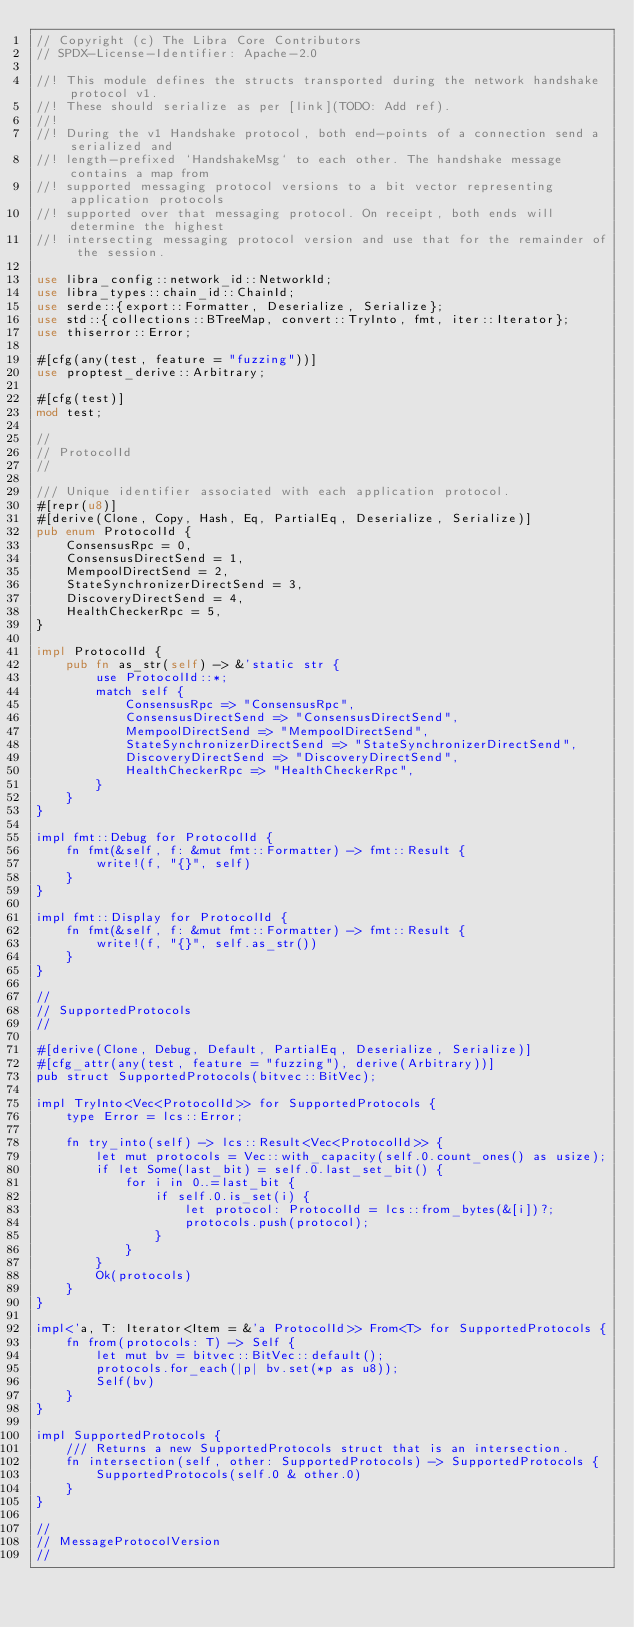<code> <loc_0><loc_0><loc_500><loc_500><_Rust_>// Copyright (c) The Libra Core Contributors
// SPDX-License-Identifier: Apache-2.0

//! This module defines the structs transported during the network handshake protocol v1.
//! These should serialize as per [link](TODO: Add ref).
//!
//! During the v1 Handshake protocol, both end-points of a connection send a serialized and
//! length-prefixed `HandshakeMsg` to each other. The handshake message contains a map from
//! supported messaging protocol versions to a bit vector representing application protocols
//! supported over that messaging protocol. On receipt, both ends will determine the highest
//! intersecting messaging protocol version and use that for the remainder of the session.

use libra_config::network_id::NetworkId;
use libra_types::chain_id::ChainId;
use serde::{export::Formatter, Deserialize, Serialize};
use std::{collections::BTreeMap, convert::TryInto, fmt, iter::Iterator};
use thiserror::Error;

#[cfg(any(test, feature = "fuzzing"))]
use proptest_derive::Arbitrary;

#[cfg(test)]
mod test;

//
// ProtocolId
//

/// Unique identifier associated with each application protocol.
#[repr(u8)]
#[derive(Clone, Copy, Hash, Eq, PartialEq, Deserialize, Serialize)]
pub enum ProtocolId {
    ConsensusRpc = 0,
    ConsensusDirectSend = 1,
    MempoolDirectSend = 2,
    StateSynchronizerDirectSend = 3,
    DiscoveryDirectSend = 4,
    HealthCheckerRpc = 5,
}

impl ProtocolId {
    pub fn as_str(self) -> &'static str {
        use ProtocolId::*;
        match self {
            ConsensusRpc => "ConsensusRpc",
            ConsensusDirectSend => "ConsensusDirectSend",
            MempoolDirectSend => "MempoolDirectSend",
            StateSynchronizerDirectSend => "StateSynchronizerDirectSend",
            DiscoveryDirectSend => "DiscoveryDirectSend",
            HealthCheckerRpc => "HealthCheckerRpc",
        }
    }
}

impl fmt::Debug for ProtocolId {
    fn fmt(&self, f: &mut fmt::Formatter) -> fmt::Result {
        write!(f, "{}", self)
    }
}

impl fmt::Display for ProtocolId {
    fn fmt(&self, f: &mut fmt::Formatter) -> fmt::Result {
        write!(f, "{}", self.as_str())
    }
}

//
// SupportedProtocols
//

#[derive(Clone, Debug, Default, PartialEq, Deserialize, Serialize)]
#[cfg_attr(any(test, feature = "fuzzing"), derive(Arbitrary))]
pub struct SupportedProtocols(bitvec::BitVec);

impl TryInto<Vec<ProtocolId>> for SupportedProtocols {
    type Error = lcs::Error;

    fn try_into(self) -> lcs::Result<Vec<ProtocolId>> {
        let mut protocols = Vec::with_capacity(self.0.count_ones() as usize);
        if let Some(last_bit) = self.0.last_set_bit() {
            for i in 0..=last_bit {
                if self.0.is_set(i) {
                    let protocol: ProtocolId = lcs::from_bytes(&[i])?;
                    protocols.push(protocol);
                }
            }
        }
        Ok(protocols)
    }
}

impl<'a, T: Iterator<Item = &'a ProtocolId>> From<T> for SupportedProtocols {
    fn from(protocols: T) -> Self {
        let mut bv = bitvec::BitVec::default();
        protocols.for_each(|p| bv.set(*p as u8));
        Self(bv)
    }
}

impl SupportedProtocols {
    /// Returns a new SupportedProtocols struct that is an intersection.
    fn intersection(self, other: SupportedProtocols) -> SupportedProtocols {
        SupportedProtocols(self.0 & other.0)
    }
}

//
// MessageProtocolVersion
//
</code> 